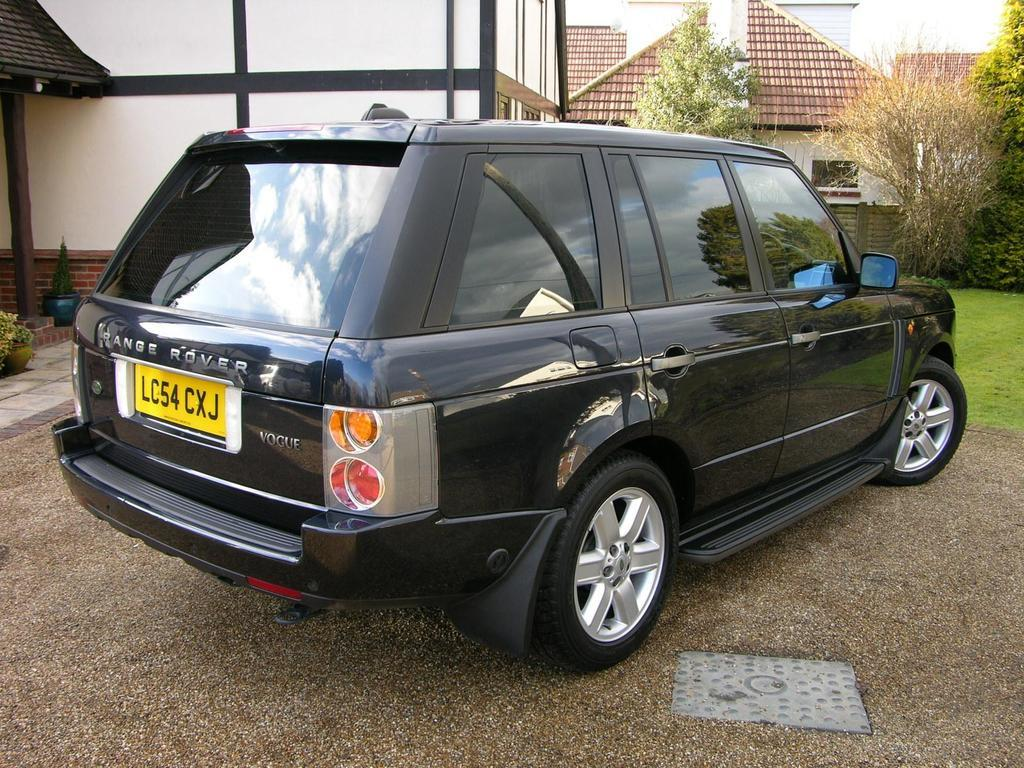What type of vehicle is in the image? There is a black car in the image. Where is the car located in relation to other objects? The car is parked near a building. What can be seen in the background of the image? There are windows, trees, plants, grass, and the sky visible in the background of the image. What type of stem is visible on the car in the image? There is no stem visible on the car in the image. What company is associated with the car in the image? The image does not provide information about the car's manufacturer or any associated company. 